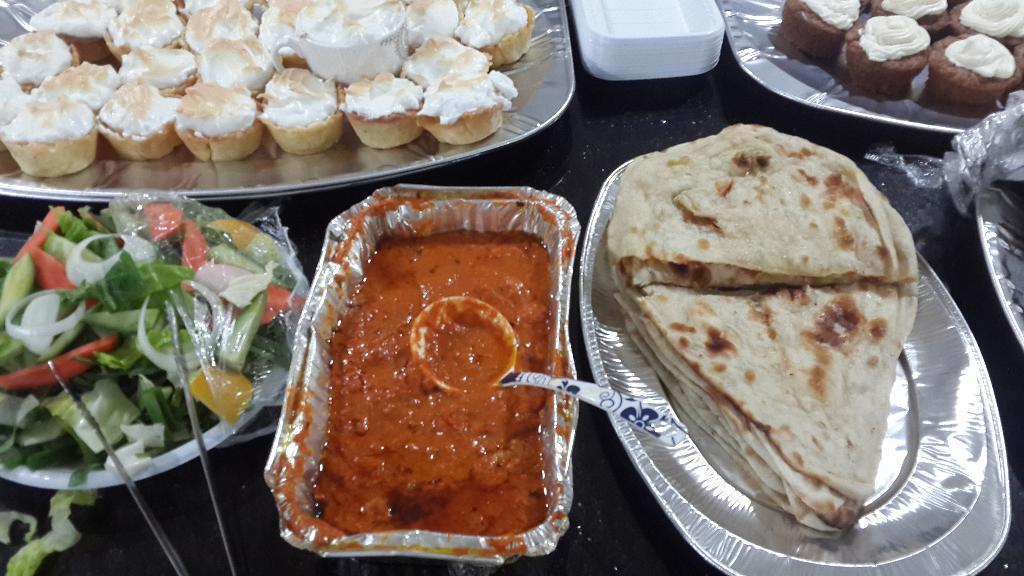What piece of furniture is present in the image? There is a table in the image. What items are placed on the table? There are plates, cupcakes, vegetables, parathas, and curries on the table. What type of food can be seen on the table? Cupcakes, vegetables, parathas, and curries are visible on the table. What color is the sheet covering the dog in the image? There is no sheet or dog present in the image; it only features a table with various food items. 